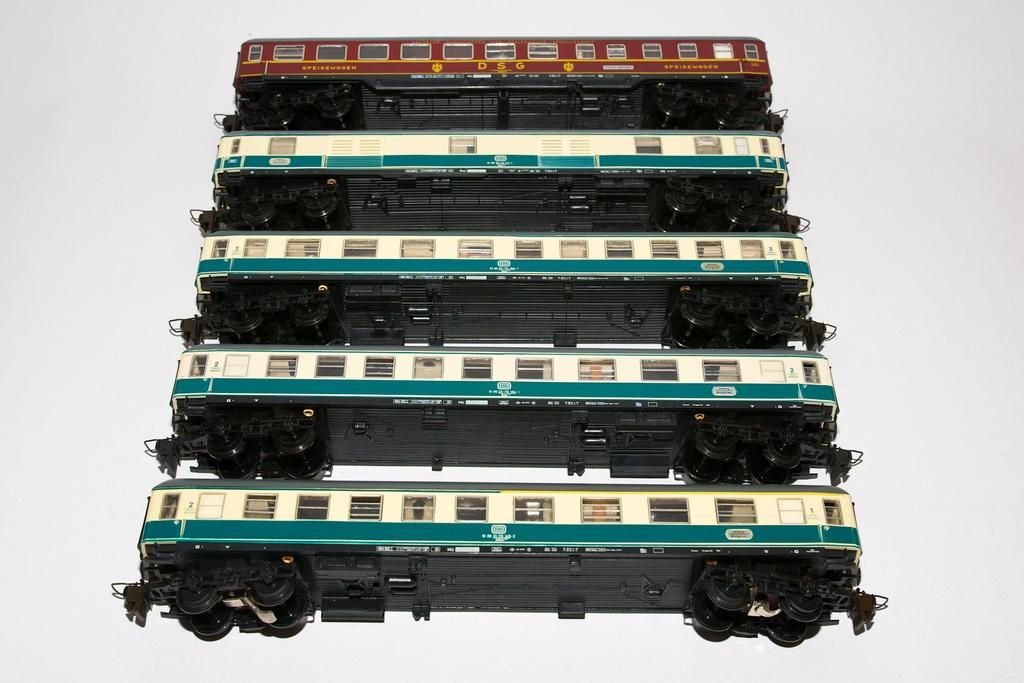What type of transportation is depicted in the image? The image contains railway compartments. Can you describe the railway compartments in the image? Unfortunately, the provided facts do not include any details about the railway compartments. Are there any other elements in the image besides the railway compartments? The provided facts do not mention any other elements in the image. What type of wool is being used to cover the railway compartments in the image? There is no wool present in the image, as it features railway compartments. How does the sun affect the visibility of the railway compartments in the image? The provided facts do not mention the presence of the sun or any weather conditions in the image. 